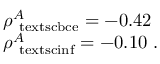Convert formula to latex. <formula><loc_0><loc_0><loc_500><loc_500>\begin{array} { l l } { \rho _ { \ t e x t s c { b c e } } ^ { A } = - 0 . 4 2 } \\ { \rho _ { \ t e x t s c { i n f } } ^ { A } = - 0 . 1 0 . } \end{array}</formula> 